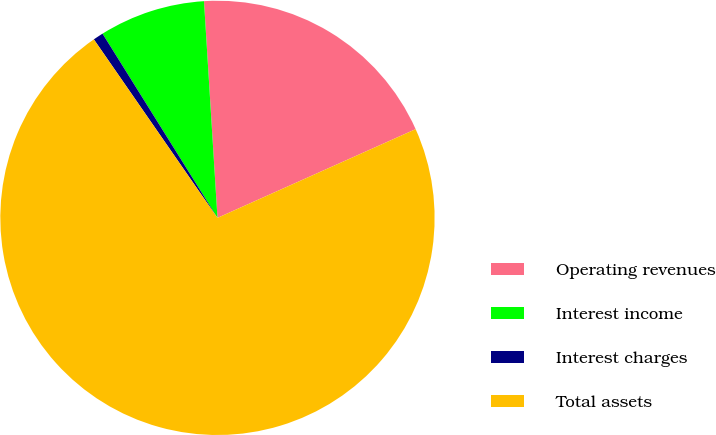Convert chart to OTSL. <chart><loc_0><loc_0><loc_500><loc_500><pie_chart><fcel>Operating revenues<fcel>Interest income<fcel>Interest charges<fcel>Total assets<nl><fcel>19.29%<fcel>7.89%<fcel>0.76%<fcel>72.06%<nl></chart> 